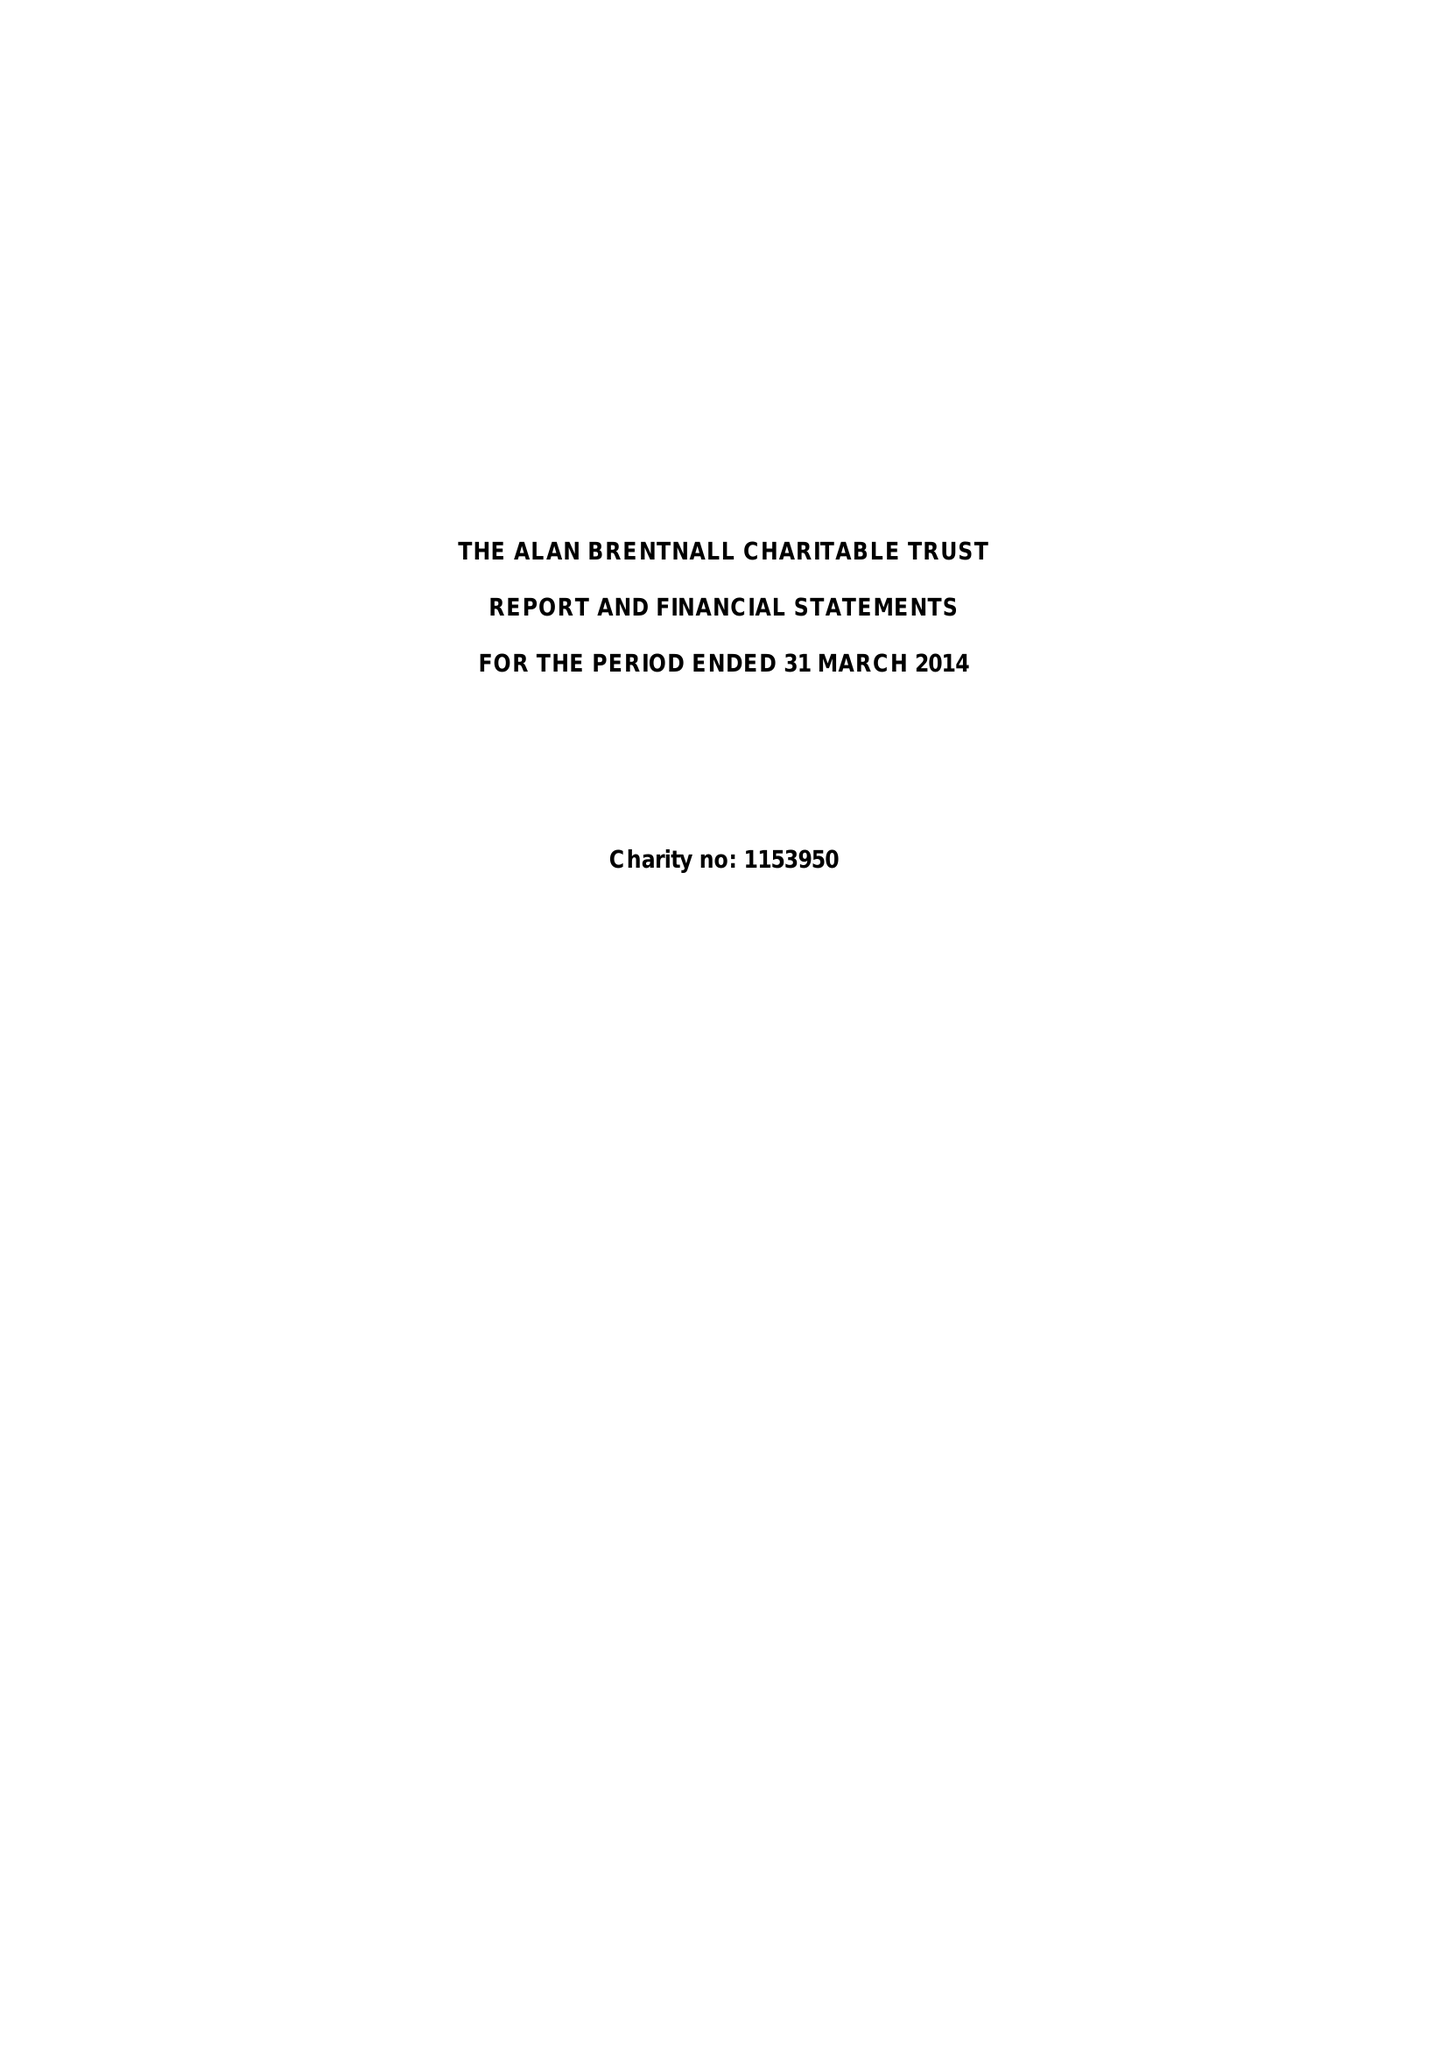What is the value for the address__postcode?
Answer the question using a single word or phrase. IV36 1DR 